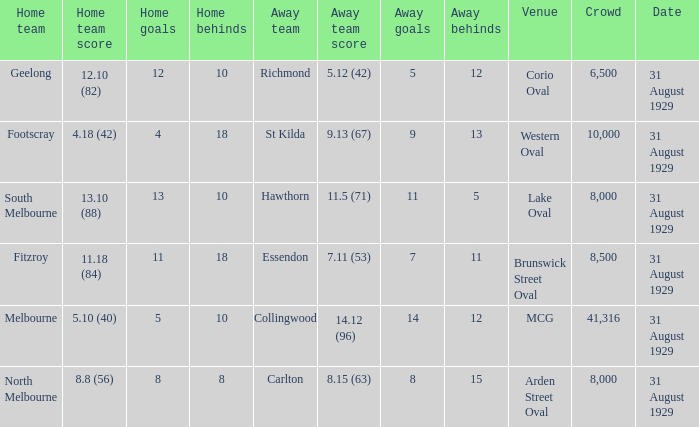What date was the game when the away team was carlton? 31 August 1929. 